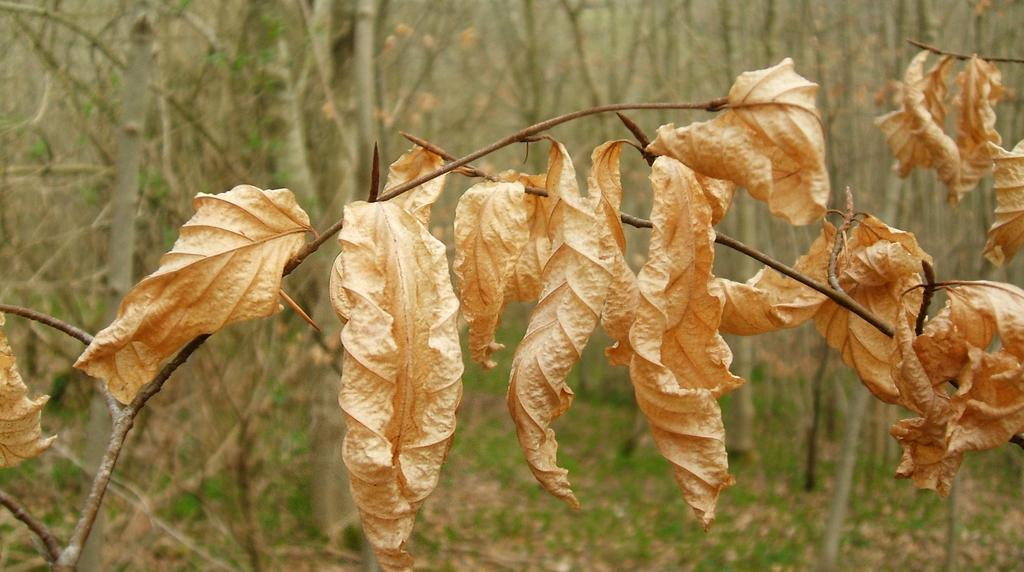What is the main subject of the image? The main subject of the image is a stem with leaves. Can you describe the background of the image? There are trees in the background of the image. What type of curtain can be seen hanging from the leaves in the image? There is no curtain present in the image; it features a stem with leaves and trees in the background. 